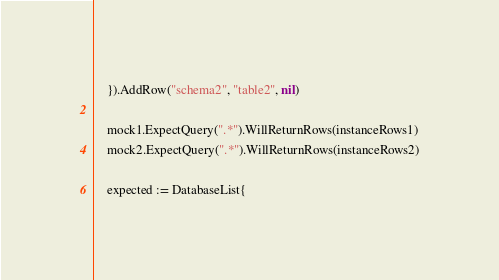Convert code to text. <code><loc_0><loc_0><loc_500><loc_500><_Go_>	}).AddRow("schema2", "table2", nil)

	mock1.ExpectQuery(".*").WillReturnRows(instanceRows1)
	mock2.ExpectQuery(".*").WillReturnRows(instanceRows2)

	expected := DatabaseList{</code> 